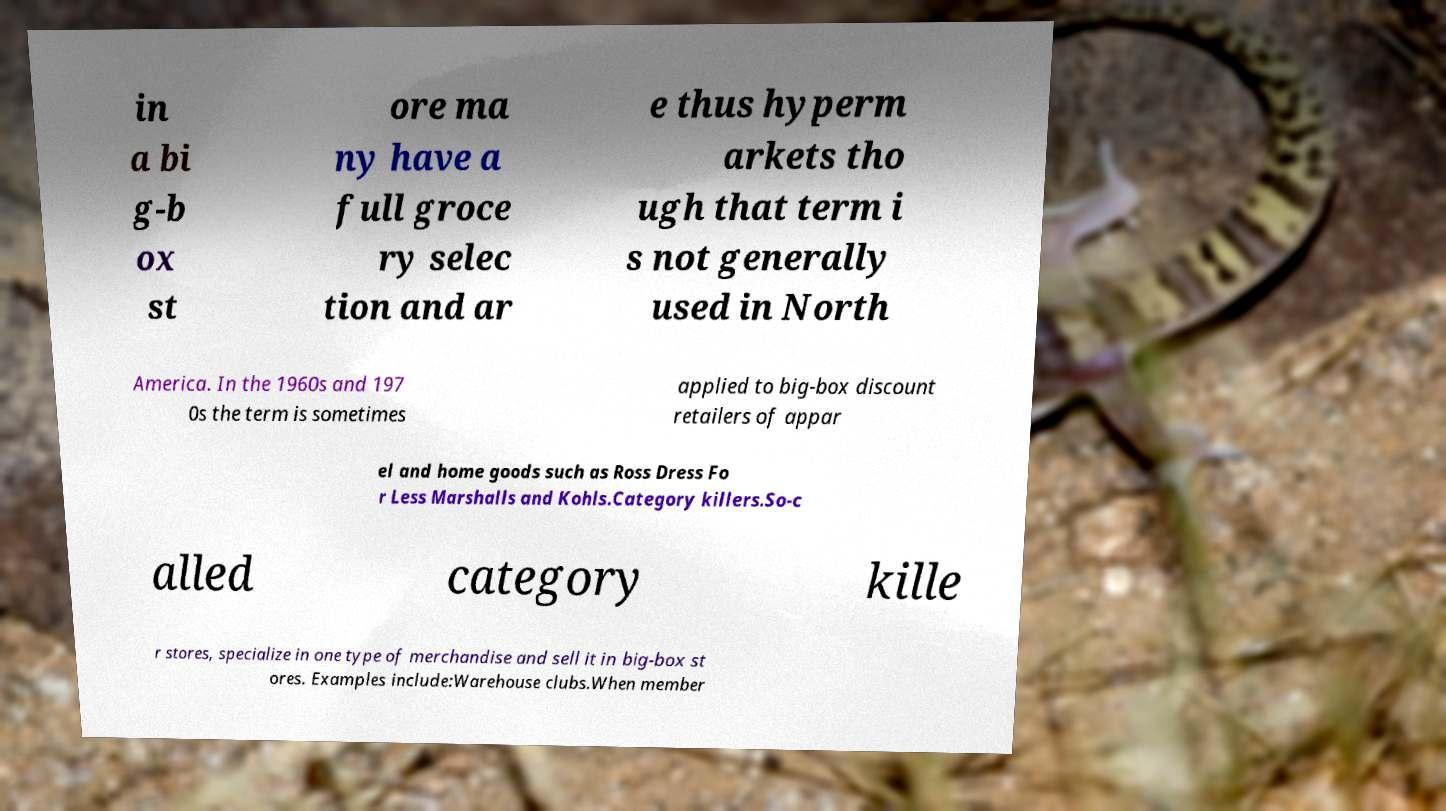Please read and relay the text visible in this image. What does it say? in a bi g-b ox st ore ma ny have a full groce ry selec tion and ar e thus hyperm arkets tho ugh that term i s not generally used in North America. In the 1960s and 197 0s the term is sometimes applied to big-box discount retailers of appar el and home goods such as Ross Dress Fo r Less Marshalls and Kohls.Category killers.So-c alled category kille r stores, specialize in one type of merchandise and sell it in big-box st ores. Examples include:Warehouse clubs.When member 